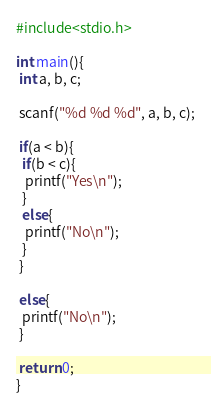Convert code to text. <code><loc_0><loc_0><loc_500><loc_500><_C_>#include<stdio.h>

int main(){
 int a, b, c;

 scanf("%d %d %d", a, b, c);

 if(a < b){
  if(b < c){
   printf("Yes\n");
  }
  else{
   printf("No\n");
  }
 }

 else{
  printf("No\n");
 }

 return 0;
}</code> 